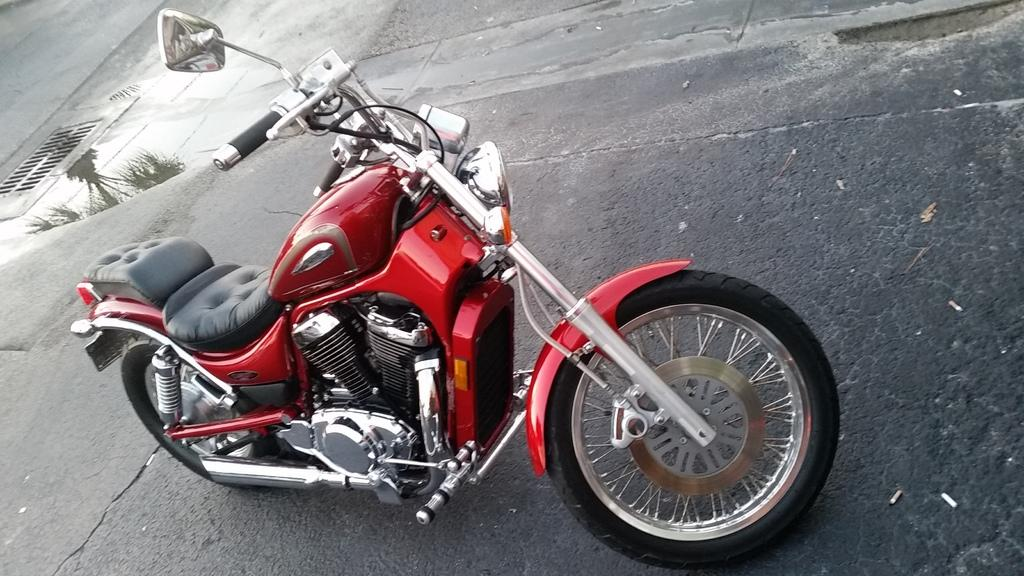What is the main subject in the center of the image? There is a motorbike in the center of the image. What type of surface is visible at the bottom of the image? There is a road at the bottom of the image. What type of fang can be seen on the motorbike in the image? There are no fangs present on the motorbike in the image. What discovery was made while riding the motorbike in the image? There is no indication of a discovery being made in the image; it simply shows a motorbike on a road. 